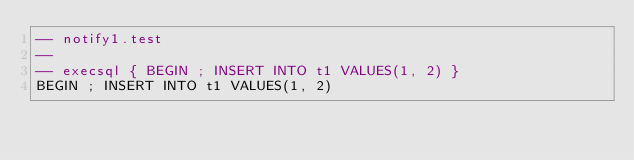Convert code to text. <code><loc_0><loc_0><loc_500><loc_500><_SQL_>-- notify1.test
-- 
-- execsql { BEGIN ; INSERT INTO t1 VALUES(1, 2) }
BEGIN ; INSERT INTO t1 VALUES(1, 2)</code> 